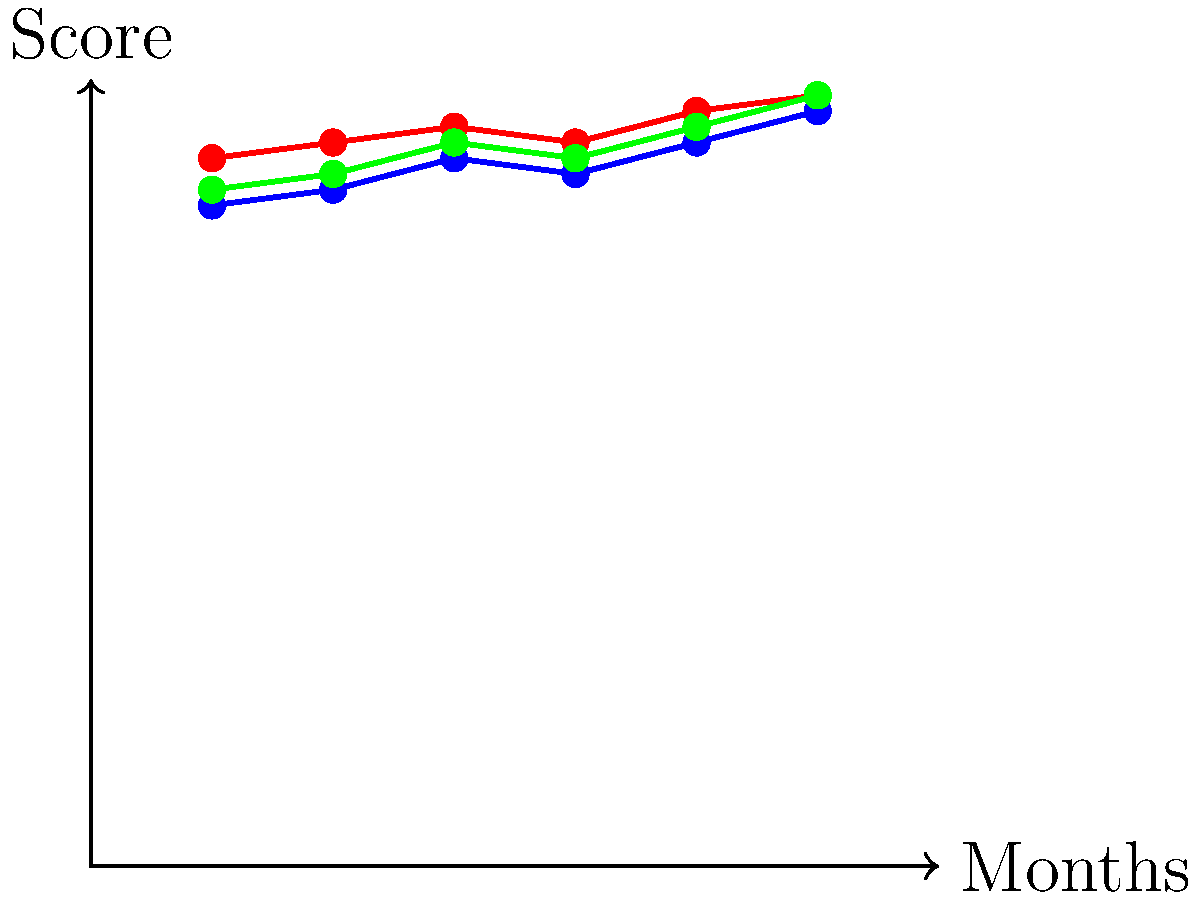As a bed and breakfast host, you've been tracking guest satisfaction scores over the past six months. The graph shows trends for overall satisfaction, cleanliness, and hospitality. Which aspect of your service shows the most consistent improvement, and what is the difference between its highest and lowest scores? To answer this question, we need to analyze the trends for each aspect of service:

1. Overall satisfaction:
   - Starts at 4.2 and ends at 4.8
   - Shows improvement but with some fluctuations

2. Cleanliness:
   - Starts at 4.5 and ends at 4.9
   - Shows steady improvement with one small dip

3. Hospitality:
   - Starts at 4.3 and ends at 4.9
   - Shows the most consistent upward trend

Hospitality demonstrates the most consistent improvement, with a steady upward trend and no significant dips.

To calculate the difference between the highest and lowest scores for hospitality:
- Highest score: 4.9 (Month 6)
- Lowest score: 4.3 (Month 1)
- Difference: $4.9 - 4.3 = 0.6$
Answer: Hospitality; 0.6 